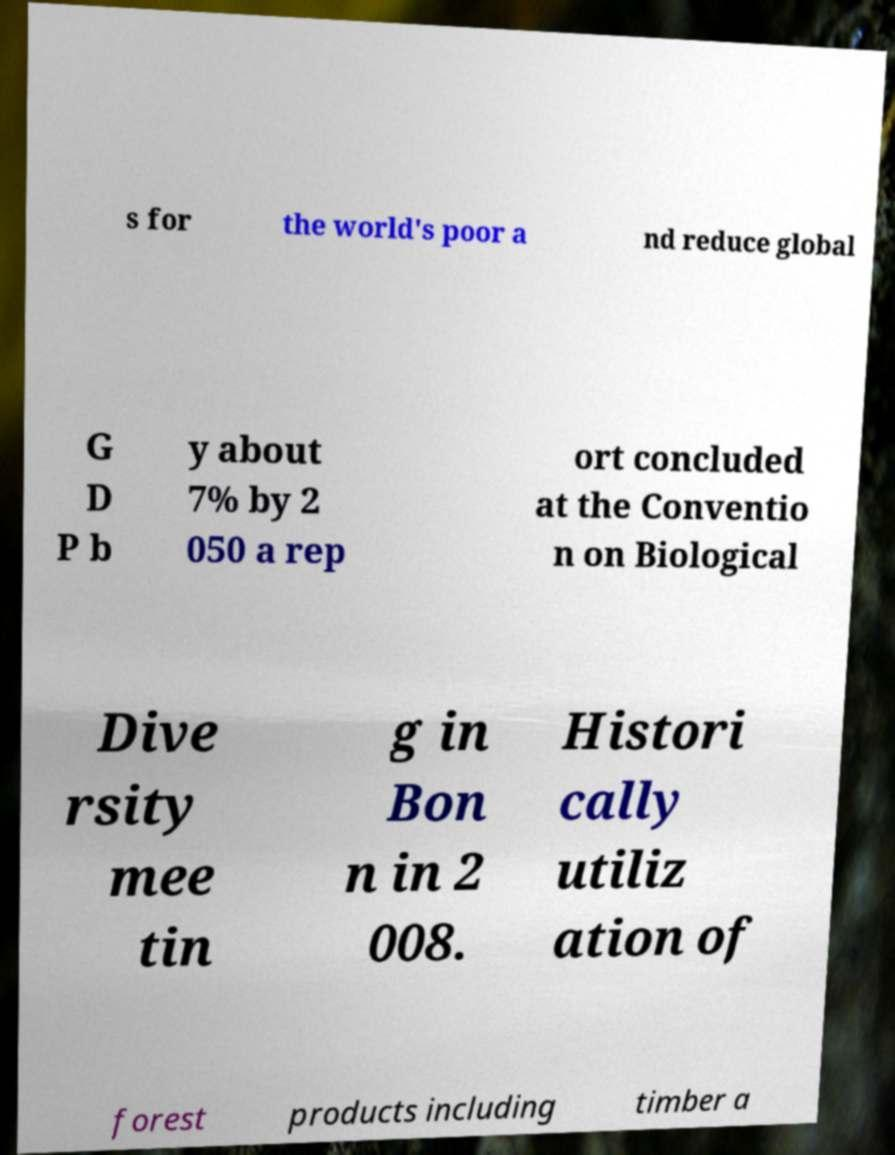Could you extract and type out the text from this image? s for the world's poor a nd reduce global G D P b y about 7% by 2 050 a rep ort concluded at the Conventio n on Biological Dive rsity mee tin g in Bon n in 2 008. Histori cally utiliz ation of forest products including timber a 